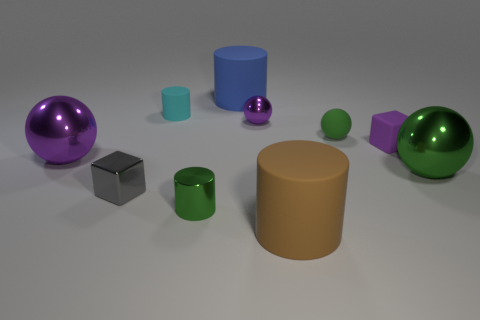Subtract all cyan blocks. Subtract all brown balls. How many blocks are left? 2 Subtract all cubes. How many objects are left? 8 Add 1 tiny blue shiny balls. How many tiny blue shiny balls exist? 1 Subtract 2 green spheres. How many objects are left? 8 Subtract all blue objects. Subtract all tiny shiny cubes. How many objects are left? 8 Add 9 blue matte objects. How many blue matte objects are left? 10 